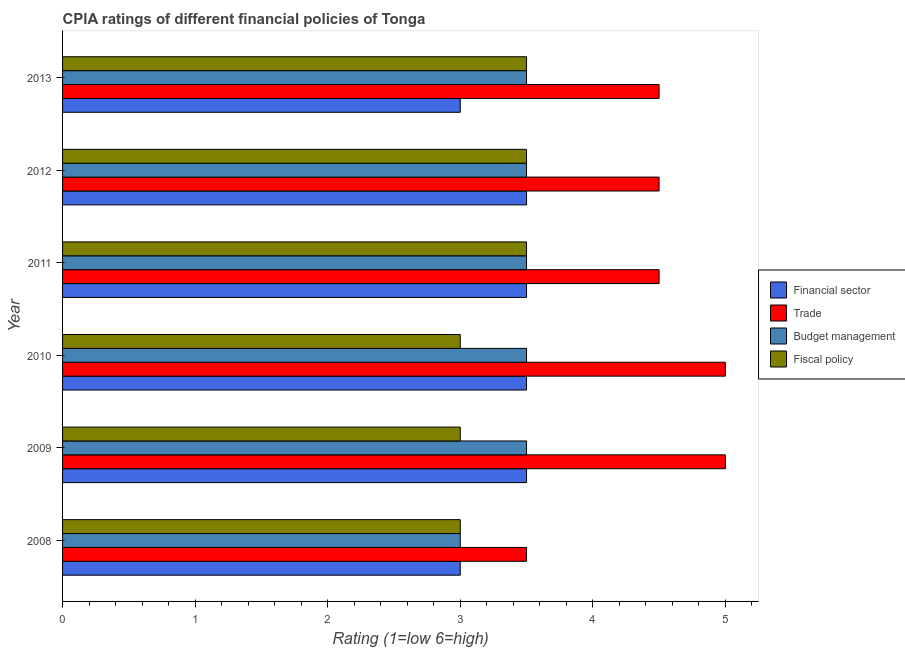Are the number of bars per tick equal to the number of legend labels?
Your response must be concise. Yes. How many bars are there on the 5th tick from the bottom?
Make the answer very short. 4. In how many cases, is the number of bars for a given year not equal to the number of legend labels?
Your answer should be compact. 0. What is the cpia rating of fiscal policy in 2011?
Offer a terse response. 3.5. In which year was the cpia rating of budget management minimum?
Keep it short and to the point. 2008. What is the total cpia rating of trade in the graph?
Provide a succinct answer. 27. What is the difference between the cpia rating of fiscal policy in 2008 and that in 2010?
Your answer should be very brief. 0. What is the difference between the cpia rating of fiscal policy in 2009 and the cpia rating of trade in 2011?
Provide a short and direct response. -1.5. What is the average cpia rating of financial sector per year?
Keep it short and to the point. 3.33. In how many years, is the cpia rating of fiscal policy greater than 0.8 ?
Give a very brief answer. 6. What is the ratio of the cpia rating of financial sector in 2008 to that in 2011?
Make the answer very short. 0.86. What is the difference between the highest and the second highest cpia rating of budget management?
Your answer should be compact. 0. What is the difference between the highest and the lowest cpia rating of fiscal policy?
Offer a very short reply. 0.5. What does the 4th bar from the top in 2009 represents?
Offer a terse response. Financial sector. What does the 1st bar from the bottom in 2012 represents?
Offer a very short reply. Financial sector. How many bars are there?
Make the answer very short. 24. Are all the bars in the graph horizontal?
Offer a very short reply. Yes. How many years are there in the graph?
Offer a terse response. 6. Are the values on the major ticks of X-axis written in scientific E-notation?
Ensure brevity in your answer.  No. Does the graph contain grids?
Keep it short and to the point. No. Where does the legend appear in the graph?
Keep it short and to the point. Center right. How many legend labels are there?
Ensure brevity in your answer.  4. How are the legend labels stacked?
Provide a succinct answer. Vertical. What is the title of the graph?
Your answer should be compact. CPIA ratings of different financial policies of Tonga. What is the label or title of the X-axis?
Make the answer very short. Rating (1=low 6=high). What is the label or title of the Y-axis?
Ensure brevity in your answer.  Year. What is the Rating (1=low 6=high) of Trade in 2008?
Keep it short and to the point. 3.5. What is the Rating (1=low 6=high) of Financial sector in 2009?
Make the answer very short. 3.5. What is the Rating (1=low 6=high) of Budget management in 2009?
Make the answer very short. 3.5. What is the Rating (1=low 6=high) of Financial sector in 2010?
Your answer should be very brief. 3.5. What is the Rating (1=low 6=high) in Trade in 2010?
Provide a succinct answer. 5. What is the Rating (1=low 6=high) of Budget management in 2010?
Make the answer very short. 3.5. What is the Rating (1=low 6=high) in Fiscal policy in 2010?
Your response must be concise. 3. What is the Rating (1=low 6=high) in Trade in 2011?
Provide a short and direct response. 4.5. What is the Rating (1=low 6=high) in Trade in 2012?
Provide a succinct answer. 4.5. What is the Rating (1=low 6=high) in Budget management in 2012?
Your response must be concise. 3.5. What is the Rating (1=low 6=high) in Financial sector in 2013?
Your answer should be compact. 3. What is the Rating (1=low 6=high) of Trade in 2013?
Ensure brevity in your answer.  4.5. Across all years, what is the maximum Rating (1=low 6=high) in Financial sector?
Your answer should be compact. 3.5. Across all years, what is the maximum Rating (1=low 6=high) of Fiscal policy?
Make the answer very short. 3.5. What is the total Rating (1=low 6=high) in Financial sector in the graph?
Offer a terse response. 20. What is the difference between the Rating (1=low 6=high) in Financial sector in 2008 and that in 2009?
Keep it short and to the point. -0.5. What is the difference between the Rating (1=low 6=high) in Trade in 2008 and that in 2009?
Your answer should be compact. -1.5. What is the difference between the Rating (1=low 6=high) in Fiscal policy in 2008 and that in 2009?
Your response must be concise. 0. What is the difference between the Rating (1=low 6=high) of Trade in 2008 and that in 2010?
Provide a short and direct response. -1.5. What is the difference between the Rating (1=low 6=high) of Budget management in 2008 and that in 2010?
Keep it short and to the point. -0.5. What is the difference between the Rating (1=low 6=high) of Financial sector in 2008 and that in 2011?
Provide a short and direct response. -0.5. What is the difference between the Rating (1=low 6=high) in Trade in 2008 and that in 2011?
Your response must be concise. -1. What is the difference between the Rating (1=low 6=high) in Trade in 2008 and that in 2012?
Make the answer very short. -1. What is the difference between the Rating (1=low 6=high) in Budget management in 2008 and that in 2012?
Ensure brevity in your answer.  -0.5. What is the difference between the Rating (1=low 6=high) in Financial sector in 2008 and that in 2013?
Provide a short and direct response. 0. What is the difference between the Rating (1=low 6=high) of Fiscal policy in 2008 and that in 2013?
Give a very brief answer. -0.5. What is the difference between the Rating (1=low 6=high) of Financial sector in 2009 and that in 2010?
Offer a terse response. 0. What is the difference between the Rating (1=low 6=high) in Budget management in 2009 and that in 2010?
Your answer should be compact. 0. What is the difference between the Rating (1=low 6=high) in Financial sector in 2009 and that in 2011?
Your answer should be very brief. 0. What is the difference between the Rating (1=low 6=high) in Trade in 2009 and that in 2011?
Keep it short and to the point. 0.5. What is the difference between the Rating (1=low 6=high) of Fiscal policy in 2009 and that in 2011?
Provide a short and direct response. -0.5. What is the difference between the Rating (1=low 6=high) in Fiscal policy in 2009 and that in 2012?
Your answer should be compact. -0.5. What is the difference between the Rating (1=low 6=high) of Financial sector in 2009 and that in 2013?
Your answer should be compact. 0.5. What is the difference between the Rating (1=low 6=high) of Budget management in 2010 and that in 2011?
Make the answer very short. 0. What is the difference between the Rating (1=low 6=high) of Fiscal policy in 2010 and that in 2011?
Your response must be concise. -0.5. What is the difference between the Rating (1=low 6=high) in Financial sector in 2010 and that in 2012?
Make the answer very short. 0. What is the difference between the Rating (1=low 6=high) of Budget management in 2010 and that in 2012?
Provide a short and direct response. 0. What is the difference between the Rating (1=low 6=high) of Trade in 2010 and that in 2013?
Provide a short and direct response. 0.5. What is the difference between the Rating (1=low 6=high) in Budget management in 2011 and that in 2012?
Give a very brief answer. 0. What is the difference between the Rating (1=low 6=high) of Fiscal policy in 2011 and that in 2012?
Provide a short and direct response. 0. What is the difference between the Rating (1=low 6=high) in Trade in 2011 and that in 2013?
Your answer should be very brief. 0. What is the difference between the Rating (1=low 6=high) of Financial sector in 2012 and that in 2013?
Your answer should be very brief. 0.5. What is the difference between the Rating (1=low 6=high) in Trade in 2012 and that in 2013?
Make the answer very short. 0. What is the difference between the Rating (1=low 6=high) of Budget management in 2012 and that in 2013?
Give a very brief answer. 0. What is the difference between the Rating (1=low 6=high) of Fiscal policy in 2012 and that in 2013?
Provide a short and direct response. 0. What is the difference between the Rating (1=low 6=high) of Financial sector in 2008 and the Rating (1=low 6=high) of Trade in 2009?
Keep it short and to the point. -2. What is the difference between the Rating (1=low 6=high) in Financial sector in 2008 and the Rating (1=low 6=high) in Budget management in 2009?
Provide a short and direct response. -0.5. What is the difference between the Rating (1=low 6=high) of Trade in 2008 and the Rating (1=low 6=high) of Budget management in 2009?
Your answer should be very brief. 0. What is the difference between the Rating (1=low 6=high) of Trade in 2008 and the Rating (1=low 6=high) of Fiscal policy in 2009?
Offer a very short reply. 0.5. What is the difference between the Rating (1=low 6=high) of Budget management in 2008 and the Rating (1=low 6=high) of Fiscal policy in 2009?
Make the answer very short. 0. What is the difference between the Rating (1=low 6=high) of Financial sector in 2008 and the Rating (1=low 6=high) of Trade in 2010?
Offer a terse response. -2. What is the difference between the Rating (1=low 6=high) of Trade in 2008 and the Rating (1=low 6=high) of Budget management in 2010?
Offer a terse response. 0. What is the difference between the Rating (1=low 6=high) of Trade in 2008 and the Rating (1=low 6=high) of Fiscal policy in 2010?
Provide a succinct answer. 0.5. What is the difference between the Rating (1=low 6=high) of Budget management in 2008 and the Rating (1=low 6=high) of Fiscal policy in 2010?
Ensure brevity in your answer.  0. What is the difference between the Rating (1=low 6=high) in Financial sector in 2008 and the Rating (1=low 6=high) in Trade in 2011?
Provide a succinct answer. -1.5. What is the difference between the Rating (1=low 6=high) of Financial sector in 2008 and the Rating (1=low 6=high) of Budget management in 2011?
Give a very brief answer. -0.5. What is the difference between the Rating (1=low 6=high) in Financial sector in 2008 and the Rating (1=low 6=high) in Fiscal policy in 2011?
Your answer should be compact. -0.5. What is the difference between the Rating (1=low 6=high) in Trade in 2008 and the Rating (1=low 6=high) in Fiscal policy in 2011?
Your answer should be compact. 0. What is the difference between the Rating (1=low 6=high) in Financial sector in 2008 and the Rating (1=low 6=high) in Fiscal policy in 2013?
Offer a terse response. -0.5. What is the difference between the Rating (1=low 6=high) in Trade in 2008 and the Rating (1=low 6=high) in Fiscal policy in 2013?
Provide a succinct answer. 0. What is the difference between the Rating (1=low 6=high) of Financial sector in 2009 and the Rating (1=low 6=high) of Trade in 2010?
Give a very brief answer. -1.5. What is the difference between the Rating (1=low 6=high) of Financial sector in 2009 and the Rating (1=low 6=high) of Fiscal policy in 2010?
Ensure brevity in your answer.  0.5. What is the difference between the Rating (1=low 6=high) of Trade in 2009 and the Rating (1=low 6=high) of Budget management in 2010?
Ensure brevity in your answer.  1.5. What is the difference between the Rating (1=low 6=high) in Budget management in 2009 and the Rating (1=low 6=high) in Fiscal policy in 2010?
Your answer should be very brief. 0.5. What is the difference between the Rating (1=low 6=high) in Financial sector in 2009 and the Rating (1=low 6=high) in Trade in 2011?
Your response must be concise. -1. What is the difference between the Rating (1=low 6=high) in Financial sector in 2009 and the Rating (1=low 6=high) in Fiscal policy in 2011?
Offer a very short reply. 0. What is the difference between the Rating (1=low 6=high) of Trade in 2009 and the Rating (1=low 6=high) of Budget management in 2011?
Your answer should be compact. 1.5. What is the difference between the Rating (1=low 6=high) of Financial sector in 2009 and the Rating (1=low 6=high) of Budget management in 2012?
Your response must be concise. 0. What is the difference between the Rating (1=low 6=high) of Financial sector in 2009 and the Rating (1=low 6=high) of Fiscal policy in 2012?
Give a very brief answer. 0. What is the difference between the Rating (1=low 6=high) of Trade in 2009 and the Rating (1=low 6=high) of Budget management in 2012?
Offer a very short reply. 1.5. What is the difference between the Rating (1=low 6=high) in Financial sector in 2009 and the Rating (1=low 6=high) in Budget management in 2013?
Ensure brevity in your answer.  0. What is the difference between the Rating (1=low 6=high) in Financial sector in 2009 and the Rating (1=low 6=high) in Fiscal policy in 2013?
Give a very brief answer. 0. What is the difference between the Rating (1=low 6=high) of Trade in 2009 and the Rating (1=low 6=high) of Budget management in 2013?
Ensure brevity in your answer.  1.5. What is the difference between the Rating (1=low 6=high) of Financial sector in 2010 and the Rating (1=low 6=high) of Fiscal policy in 2011?
Offer a terse response. 0. What is the difference between the Rating (1=low 6=high) of Trade in 2010 and the Rating (1=low 6=high) of Fiscal policy in 2011?
Give a very brief answer. 1.5. What is the difference between the Rating (1=low 6=high) of Budget management in 2010 and the Rating (1=low 6=high) of Fiscal policy in 2011?
Make the answer very short. 0. What is the difference between the Rating (1=low 6=high) in Trade in 2010 and the Rating (1=low 6=high) in Fiscal policy in 2012?
Your answer should be very brief. 1.5. What is the difference between the Rating (1=low 6=high) of Financial sector in 2010 and the Rating (1=low 6=high) of Trade in 2013?
Ensure brevity in your answer.  -1. What is the difference between the Rating (1=low 6=high) in Trade in 2010 and the Rating (1=low 6=high) in Fiscal policy in 2013?
Ensure brevity in your answer.  1.5. What is the difference between the Rating (1=low 6=high) in Budget management in 2010 and the Rating (1=low 6=high) in Fiscal policy in 2013?
Offer a terse response. 0. What is the difference between the Rating (1=low 6=high) in Financial sector in 2011 and the Rating (1=low 6=high) in Budget management in 2012?
Give a very brief answer. 0. What is the difference between the Rating (1=low 6=high) in Trade in 2011 and the Rating (1=low 6=high) in Budget management in 2012?
Your answer should be compact. 1. What is the difference between the Rating (1=low 6=high) in Budget management in 2011 and the Rating (1=low 6=high) in Fiscal policy in 2012?
Your response must be concise. 0. What is the difference between the Rating (1=low 6=high) of Financial sector in 2011 and the Rating (1=low 6=high) of Trade in 2013?
Offer a terse response. -1. What is the difference between the Rating (1=low 6=high) of Financial sector in 2011 and the Rating (1=low 6=high) of Budget management in 2013?
Your response must be concise. 0. What is the difference between the Rating (1=low 6=high) in Financial sector in 2011 and the Rating (1=low 6=high) in Fiscal policy in 2013?
Provide a short and direct response. 0. What is the difference between the Rating (1=low 6=high) of Trade in 2011 and the Rating (1=low 6=high) of Budget management in 2013?
Your answer should be compact. 1. What is the difference between the Rating (1=low 6=high) of Financial sector in 2012 and the Rating (1=low 6=high) of Trade in 2013?
Provide a succinct answer. -1. What is the difference between the Rating (1=low 6=high) of Financial sector in 2012 and the Rating (1=low 6=high) of Budget management in 2013?
Your response must be concise. 0. What is the difference between the Rating (1=low 6=high) of Trade in 2012 and the Rating (1=low 6=high) of Budget management in 2013?
Provide a short and direct response. 1. What is the average Rating (1=low 6=high) of Budget management per year?
Your response must be concise. 3.42. What is the average Rating (1=low 6=high) in Fiscal policy per year?
Your answer should be very brief. 3.25. In the year 2008, what is the difference between the Rating (1=low 6=high) of Financial sector and Rating (1=low 6=high) of Trade?
Offer a very short reply. -0.5. In the year 2008, what is the difference between the Rating (1=low 6=high) of Financial sector and Rating (1=low 6=high) of Fiscal policy?
Your answer should be compact. 0. In the year 2009, what is the difference between the Rating (1=low 6=high) of Financial sector and Rating (1=low 6=high) of Trade?
Your answer should be very brief. -1.5. In the year 2009, what is the difference between the Rating (1=low 6=high) in Trade and Rating (1=low 6=high) in Budget management?
Provide a short and direct response. 1.5. In the year 2009, what is the difference between the Rating (1=low 6=high) of Budget management and Rating (1=low 6=high) of Fiscal policy?
Provide a succinct answer. 0.5. In the year 2010, what is the difference between the Rating (1=low 6=high) in Financial sector and Rating (1=low 6=high) in Fiscal policy?
Ensure brevity in your answer.  0.5. In the year 2010, what is the difference between the Rating (1=low 6=high) in Trade and Rating (1=low 6=high) in Budget management?
Your answer should be very brief. 1.5. In the year 2010, what is the difference between the Rating (1=low 6=high) in Budget management and Rating (1=low 6=high) in Fiscal policy?
Make the answer very short. 0.5. In the year 2011, what is the difference between the Rating (1=low 6=high) of Financial sector and Rating (1=low 6=high) of Trade?
Make the answer very short. -1. In the year 2011, what is the difference between the Rating (1=low 6=high) of Trade and Rating (1=low 6=high) of Budget management?
Keep it short and to the point. 1. In the year 2011, what is the difference between the Rating (1=low 6=high) of Budget management and Rating (1=low 6=high) of Fiscal policy?
Give a very brief answer. 0. In the year 2012, what is the difference between the Rating (1=low 6=high) of Financial sector and Rating (1=low 6=high) of Trade?
Your response must be concise. -1. In the year 2012, what is the difference between the Rating (1=low 6=high) in Financial sector and Rating (1=low 6=high) in Budget management?
Your response must be concise. 0. In the year 2013, what is the difference between the Rating (1=low 6=high) in Financial sector and Rating (1=low 6=high) in Trade?
Your answer should be compact. -1.5. In the year 2013, what is the difference between the Rating (1=low 6=high) of Financial sector and Rating (1=low 6=high) of Fiscal policy?
Ensure brevity in your answer.  -0.5. In the year 2013, what is the difference between the Rating (1=low 6=high) in Trade and Rating (1=low 6=high) in Budget management?
Offer a terse response. 1. In the year 2013, what is the difference between the Rating (1=low 6=high) of Trade and Rating (1=low 6=high) of Fiscal policy?
Make the answer very short. 1. In the year 2013, what is the difference between the Rating (1=low 6=high) of Budget management and Rating (1=low 6=high) of Fiscal policy?
Give a very brief answer. 0. What is the ratio of the Rating (1=low 6=high) in Financial sector in 2008 to that in 2009?
Ensure brevity in your answer.  0.86. What is the ratio of the Rating (1=low 6=high) in Trade in 2008 to that in 2009?
Keep it short and to the point. 0.7. What is the ratio of the Rating (1=low 6=high) of Fiscal policy in 2008 to that in 2009?
Make the answer very short. 1. What is the ratio of the Rating (1=low 6=high) in Budget management in 2008 to that in 2011?
Your answer should be very brief. 0.86. What is the ratio of the Rating (1=low 6=high) of Financial sector in 2008 to that in 2012?
Keep it short and to the point. 0.86. What is the ratio of the Rating (1=low 6=high) in Budget management in 2008 to that in 2012?
Make the answer very short. 0.86. What is the ratio of the Rating (1=low 6=high) in Fiscal policy in 2008 to that in 2012?
Keep it short and to the point. 0.86. What is the ratio of the Rating (1=low 6=high) of Financial sector in 2008 to that in 2013?
Make the answer very short. 1. What is the ratio of the Rating (1=low 6=high) in Budget management in 2008 to that in 2013?
Your answer should be very brief. 0.86. What is the ratio of the Rating (1=low 6=high) in Fiscal policy in 2009 to that in 2010?
Ensure brevity in your answer.  1. What is the ratio of the Rating (1=low 6=high) of Financial sector in 2009 to that in 2011?
Your answer should be compact. 1. What is the ratio of the Rating (1=low 6=high) in Budget management in 2009 to that in 2011?
Your answer should be compact. 1. What is the ratio of the Rating (1=low 6=high) of Trade in 2009 to that in 2012?
Make the answer very short. 1.11. What is the ratio of the Rating (1=low 6=high) in Budget management in 2009 to that in 2012?
Offer a very short reply. 1. What is the ratio of the Rating (1=low 6=high) of Fiscal policy in 2009 to that in 2012?
Your answer should be very brief. 0.86. What is the ratio of the Rating (1=low 6=high) of Financial sector in 2009 to that in 2013?
Your response must be concise. 1.17. What is the ratio of the Rating (1=low 6=high) of Trade in 2009 to that in 2013?
Offer a very short reply. 1.11. What is the ratio of the Rating (1=low 6=high) of Trade in 2010 to that in 2011?
Make the answer very short. 1.11. What is the ratio of the Rating (1=low 6=high) in Budget management in 2010 to that in 2011?
Give a very brief answer. 1. What is the ratio of the Rating (1=low 6=high) of Fiscal policy in 2010 to that in 2011?
Keep it short and to the point. 0.86. What is the ratio of the Rating (1=low 6=high) in Financial sector in 2010 to that in 2012?
Keep it short and to the point. 1. What is the ratio of the Rating (1=low 6=high) of Budget management in 2010 to that in 2012?
Give a very brief answer. 1. What is the ratio of the Rating (1=low 6=high) of Financial sector in 2010 to that in 2013?
Offer a terse response. 1.17. What is the ratio of the Rating (1=low 6=high) in Budget management in 2010 to that in 2013?
Ensure brevity in your answer.  1. What is the ratio of the Rating (1=low 6=high) of Trade in 2011 to that in 2012?
Your answer should be compact. 1. What is the ratio of the Rating (1=low 6=high) in Budget management in 2011 to that in 2012?
Your response must be concise. 1. What is the ratio of the Rating (1=low 6=high) of Financial sector in 2011 to that in 2013?
Offer a terse response. 1.17. What is the ratio of the Rating (1=low 6=high) in Trade in 2011 to that in 2013?
Provide a succinct answer. 1. What is the ratio of the Rating (1=low 6=high) of Budget management in 2011 to that in 2013?
Your answer should be very brief. 1. What is the ratio of the Rating (1=low 6=high) in Budget management in 2012 to that in 2013?
Give a very brief answer. 1. What is the ratio of the Rating (1=low 6=high) in Fiscal policy in 2012 to that in 2013?
Offer a very short reply. 1. What is the difference between the highest and the second highest Rating (1=low 6=high) in Financial sector?
Offer a very short reply. 0. What is the difference between the highest and the second highest Rating (1=low 6=high) in Trade?
Provide a succinct answer. 0. What is the difference between the highest and the second highest Rating (1=low 6=high) of Budget management?
Your response must be concise. 0. What is the difference between the highest and the lowest Rating (1=low 6=high) in Financial sector?
Your answer should be compact. 0.5. What is the difference between the highest and the lowest Rating (1=low 6=high) of Trade?
Make the answer very short. 1.5. What is the difference between the highest and the lowest Rating (1=low 6=high) in Fiscal policy?
Your response must be concise. 0.5. 